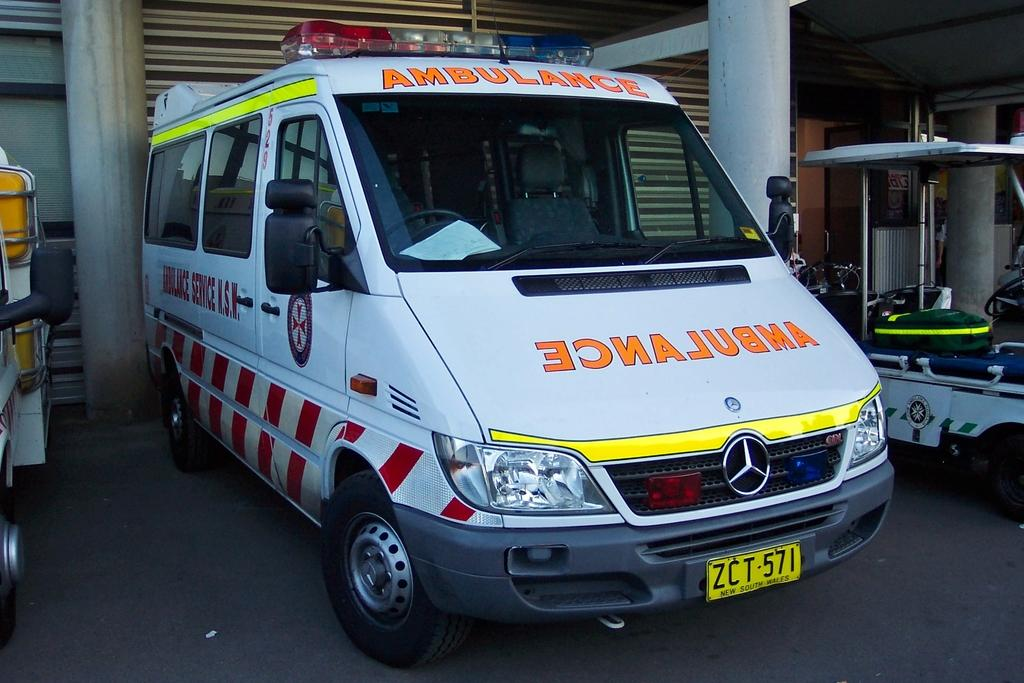What is the main subject in the middle of the image? There is a van in the middle of the image. What can be seen on the right side of the image? There is a pillar and another vehicle on the right side of the image. What is visible in the background of the image? There is a shutter and a glass visible in the background of the image. Can you hear the band playing in the background of the image? There is no band present in the image, so it is not possible to hear them playing. 